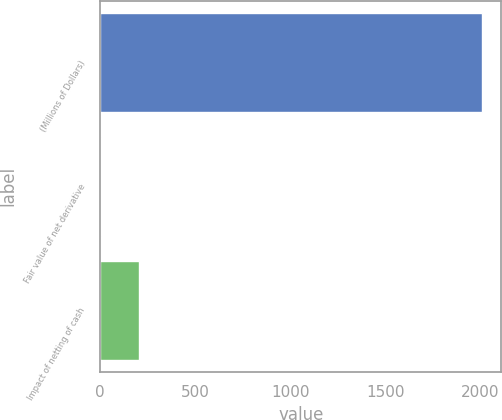Convert chart to OTSL. <chart><loc_0><loc_0><loc_500><loc_500><bar_chart><fcel>(Millions of Dollars)<fcel>Fair value of net derivative<fcel>Impact of netting of cash<nl><fcel>2012<fcel>6<fcel>206.6<nl></chart> 